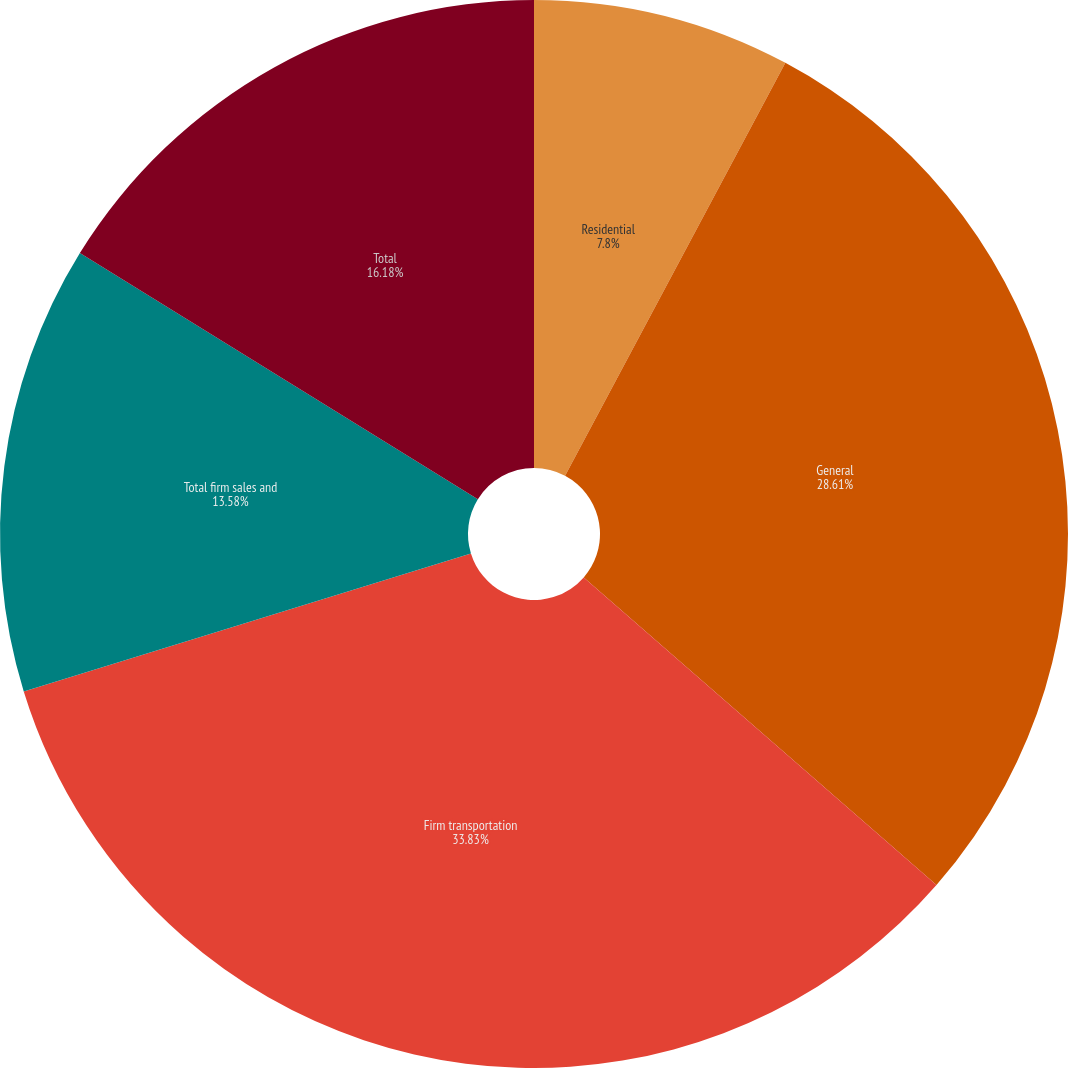Convert chart. <chart><loc_0><loc_0><loc_500><loc_500><pie_chart><fcel>Residential<fcel>General<fcel>Firm transportation<fcel>Total firm sales and<fcel>Total<nl><fcel>7.8%<fcel>28.61%<fcel>33.82%<fcel>13.58%<fcel>16.18%<nl></chart> 